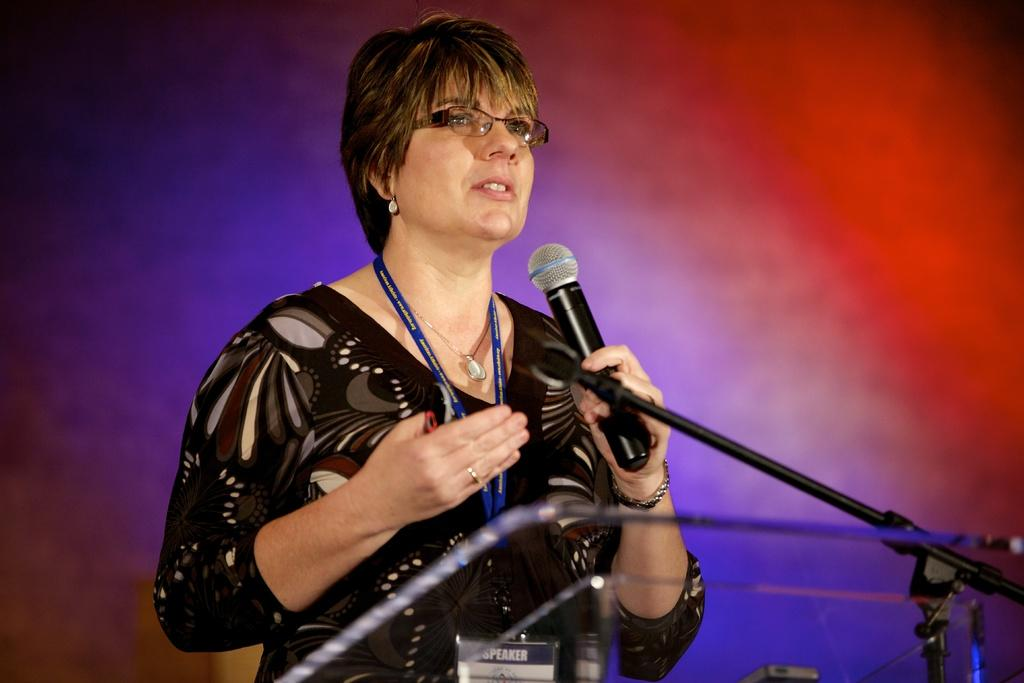Who is the main subject in the image? There is a woman in the center of the image. What is the woman holding in the image? The woman is holding a microphone. What is the woman standing in front of in the image? The woman is standing in front of a podium. What can be seen in the background of the image? There are multiple colors visible in the background of the image. How many men are visible in the image? There are no men visible in the image; the main subject is a woman. What type of respect is being shown in the image? There is no indication of respect being shown in the image; it simply depicts a woman holding a microphone and standing in front of a podium. 